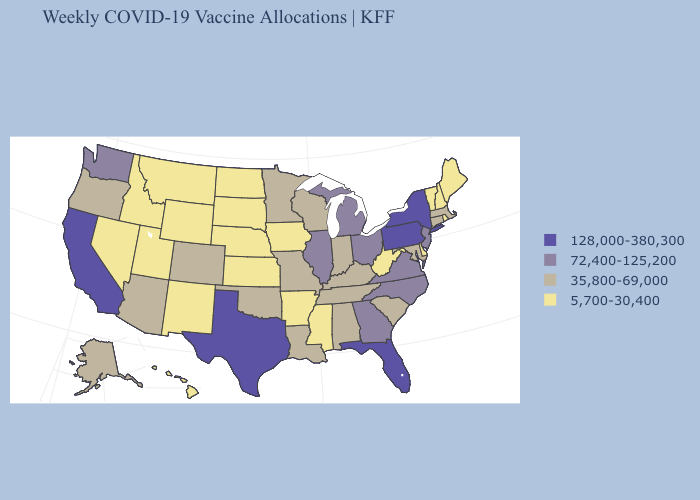Name the states that have a value in the range 35,800-69,000?
Keep it brief. Alabama, Alaska, Arizona, Colorado, Connecticut, Indiana, Kentucky, Louisiana, Maryland, Massachusetts, Minnesota, Missouri, Oklahoma, Oregon, South Carolina, Tennessee, Wisconsin. Does New Hampshire have the highest value in the Northeast?
Write a very short answer. No. Does Michigan have the highest value in the MidWest?
Quick response, please. Yes. Among the states that border California , which have the highest value?
Write a very short answer. Arizona, Oregon. What is the value of Alabama?
Concise answer only. 35,800-69,000. What is the value of Alaska?
Be succinct. 35,800-69,000. Among the states that border Pennsylvania , does Delaware have the highest value?
Keep it brief. No. Name the states that have a value in the range 72,400-125,200?
Concise answer only. Georgia, Illinois, Michigan, New Jersey, North Carolina, Ohio, Virginia, Washington. What is the lowest value in states that border Michigan?
Keep it brief. 35,800-69,000. What is the value of Idaho?
Quick response, please. 5,700-30,400. Which states have the lowest value in the West?
Give a very brief answer. Hawaii, Idaho, Montana, Nevada, New Mexico, Utah, Wyoming. Does the first symbol in the legend represent the smallest category?
Concise answer only. No. What is the value of California?
Keep it brief. 128,000-380,300. Does Rhode Island have the highest value in the Northeast?
Concise answer only. No. What is the value of Kentucky?
Give a very brief answer. 35,800-69,000. 